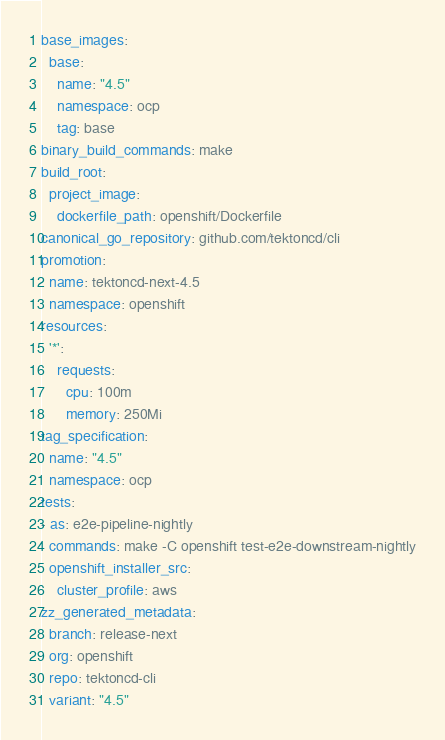<code> <loc_0><loc_0><loc_500><loc_500><_YAML_>base_images:
  base:
    name: "4.5"
    namespace: ocp
    tag: base
binary_build_commands: make
build_root:
  project_image:
    dockerfile_path: openshift/Dockerfile
canonical_go_repository: github.com/tektoncd/cli
promotion:
  name: tektoncd-next-4.5
  namespace: openshift
resources:
  '*':
    requests:
      cpu: 100m
      memory: 250Mi
tag_specification:
  name: "4.5"
  namespace: ocp
tests:
- as: e2e-pipeline-nightly
  commands: make -C openshift test-e2e-downstream-nightly
  openshift_installer_src:
    cluster_profile: aws
zz_generated_metadata:
  branch: release-next
  org: openshift
  repo: tektoncd-cli
  variant: "4.5"
</code> 